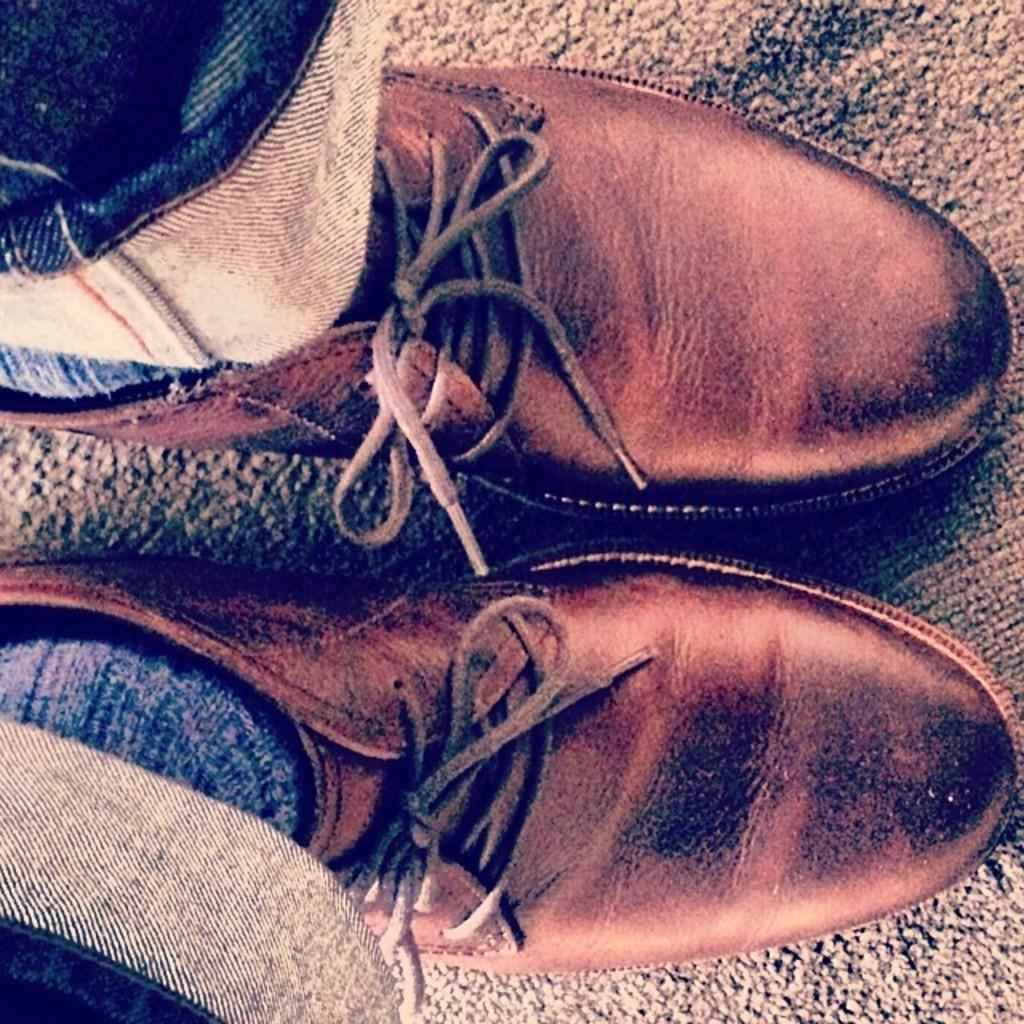Who or what is the main subject in the image? There is a person in the image. What part of the person's body can be seen? The person's legs are visible. What type of footwear is the person wearing? The person is wearing shoes. What type of pants is the person wearing? The person is wearing jeans pants. What type of sheet is covering the person's legs in the image? There is no sheet present in the image; the person's legs are visible without any covering. 